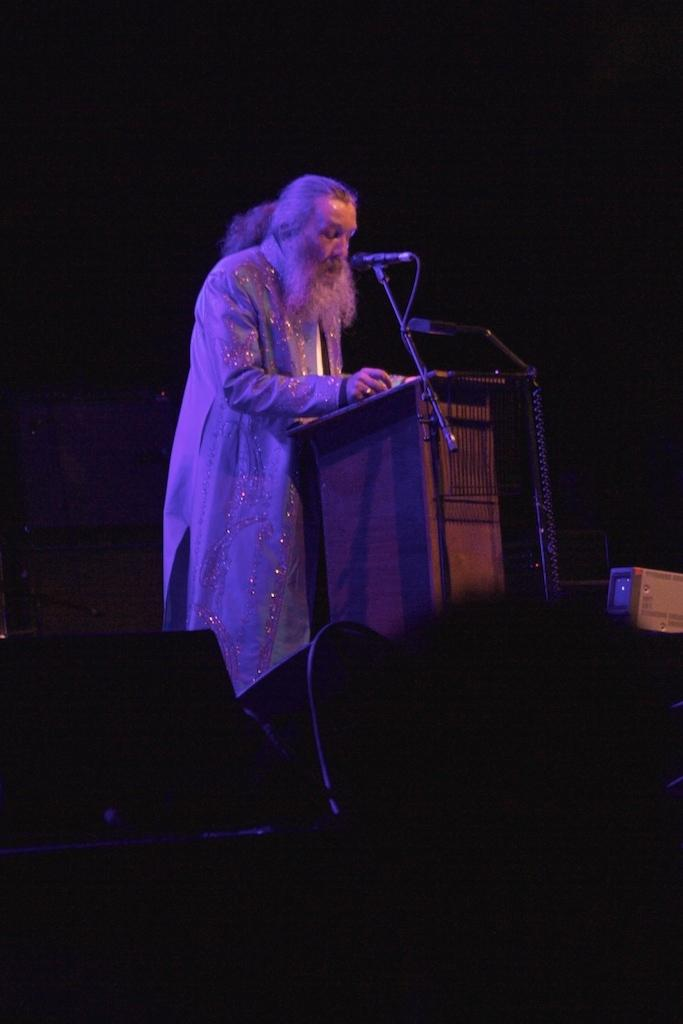Who is the main subject in the image? There is an old man in the image. What is the old man doing in the image? The old man is standing beside a podium. What is on the podium? There is a mic on the podium. What else can be seen in the image? There are speakers in the image. What is the color of the background in the image? The background of the image is dark. What type of wood is used to make the marble in the image? There is no marble present in the image, and therefore no wood used to make it. What is the old man's afterthought in the image? The provided facts do not mention any afterthoughts or thoughts of the old man, so it cannot be determined from the image. 